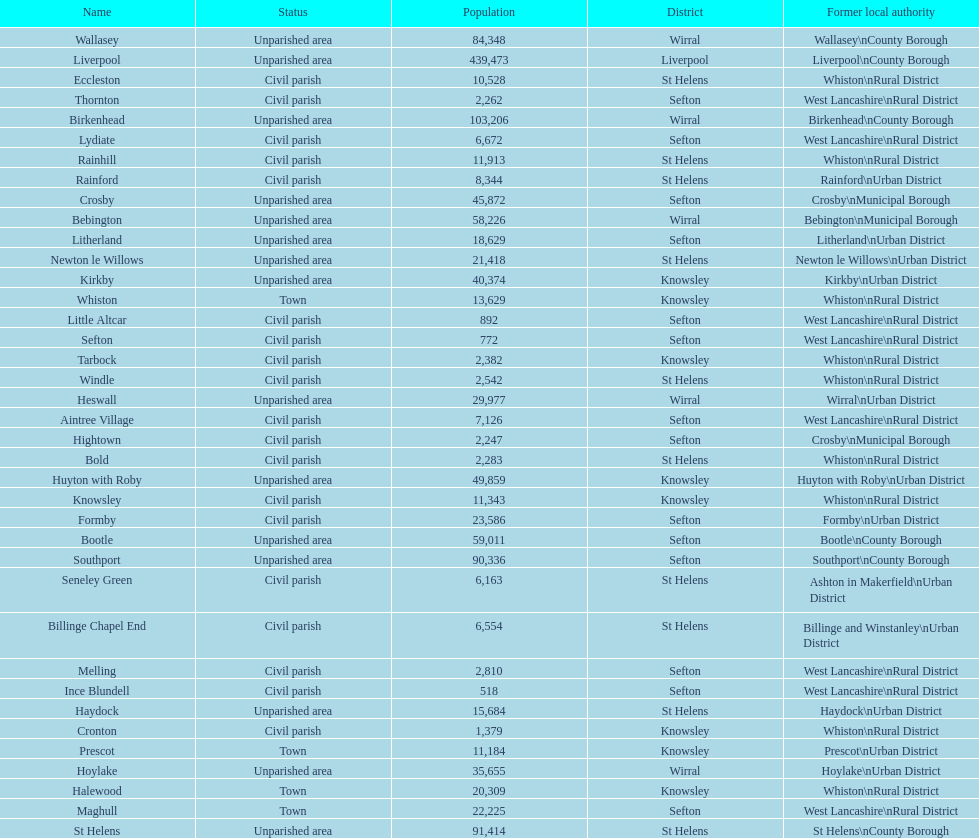How many areas are unparished areas? 15. 